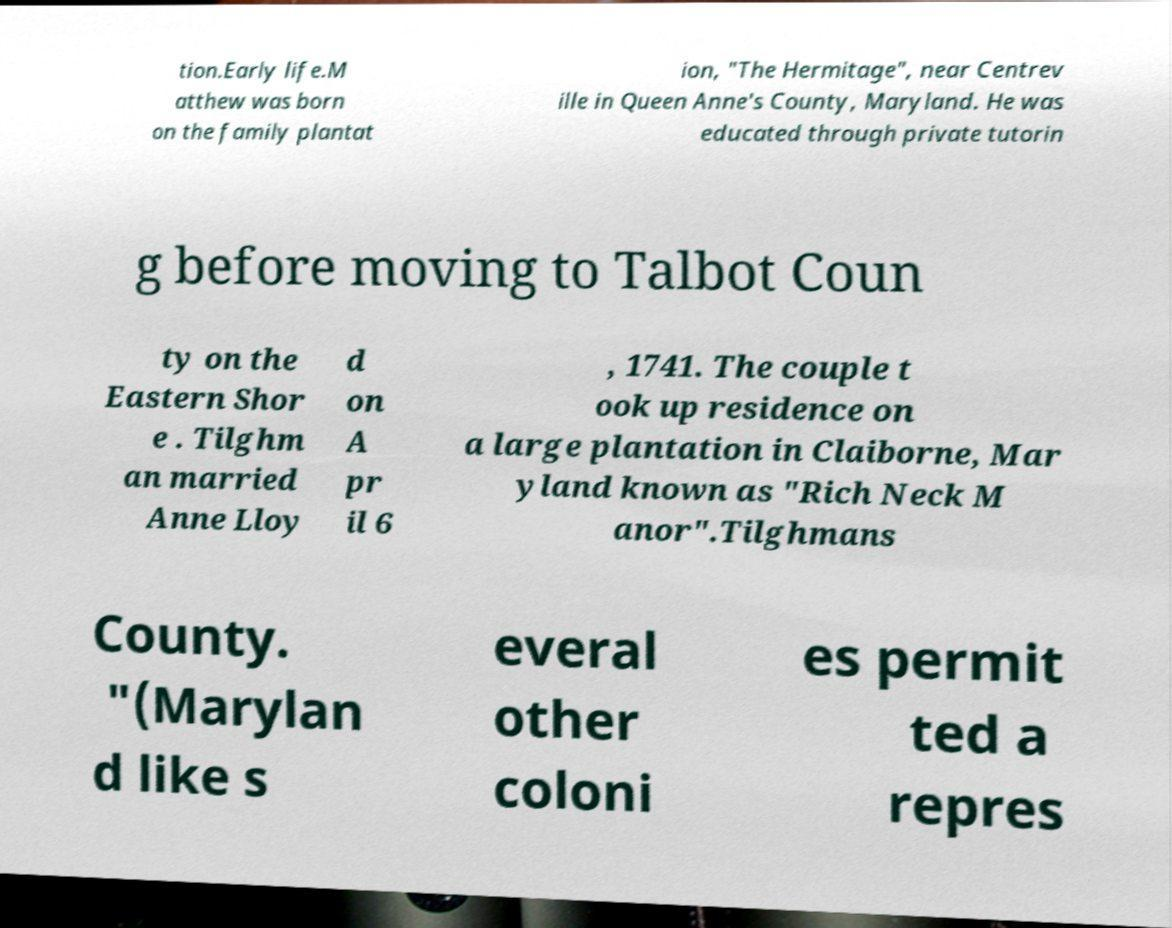There's text embedded in this image that I need extracted. Can you transcribe it verbatim? tion.Early life.M atthew was born on the family plantat ion, "The Hermitage", near Centrev ille in Queen Anne's County, Maryland. He was educated through private tutorin g before moving to Talbot Coun ty on the Eastern Shor e . Tilghm an married Anne Lloy d on A pr il 6 , 1741. The couple t ook up residence on a large plantation in Claiborne, Mar yland known as "Rich Neck M anor".Tilghmans County. "(Marylan d like s everal other coloni es permit ted a repres 